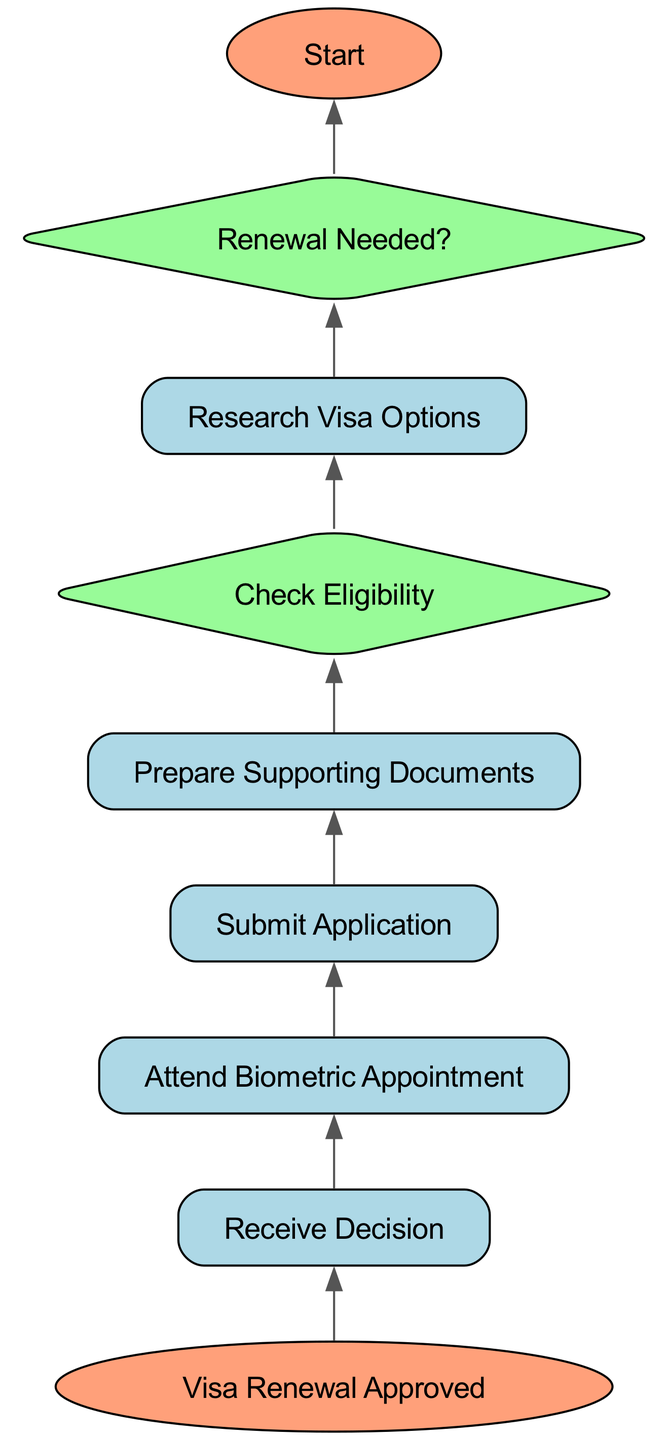What is the first step in the diagram? The diagram begins with the "Start" node, which is labeled as the first step in the visa renewal process. This node initiates the entire flow.
Answer: Start How many decision nodes are present in the diagram? The diagram contains two decision nodes: "Check Eligibility" and "Renewal Needed?" These nodes require yes/no answers to guide the process.
Answer: 2 What happens after "Attend Biometric Appointment"? The next step after "Attend Biometric Appointment" is "Receive Decision." This indicates that once biometrics are submitted, a decision on the application is awaited.
Answer: Receive Decision What is required before "Submit Application"? Before moving to "Submit Application," the step "Prepare Supporting Documents" must be completed, indicating that all necessary documents need to be gathered.
Answer: Prepare Supporting Documents What directs the flow after "Check Eligibility" if the answer is "No"? If "Check Eligibility" returns "No,", the flow does not proceed forward. The process stops at that point, indicating that the application cannot continue.
Answer: Process stops What is the outcome if "Renewal Needed?" is answered with "No"? Should the "Renewal Needed?" decision yield a "No," the process halts as it suggests that the visa does not need renewal at this time.
Answer: Process halts What is the ultimate result depicted at the end of the flowchart? The end result of successfully completing the entire visa renewal process is "Visa Renewal Approved," which signifies the successful acquisition of the renewed visa.
Answer: Visa Renewal Approved Which node follows "Research Visa Options"? The node that follows "Research Visa Options" in the diagram is "Check Eligibility." This reflects a logical progression from researching options to determining if the applicant qualifies.
Answer: Check Eligibility Which terminal node is located at the top of the diagram? At the top of the diagram, the terminal node is "Visa Renewal Approved," marking the completion of the visa renewal process.
Answer: Visa Renewal Approved 